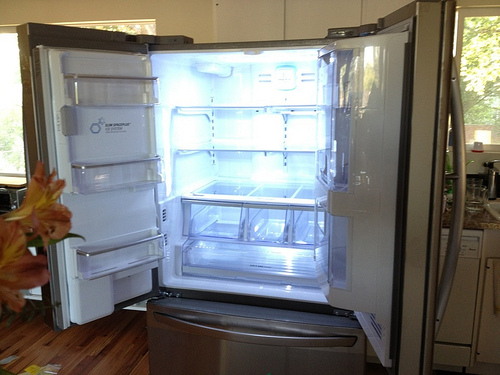Please provide the bounding box coordinate of the region this sentence describes: Large wide glass window. For a large wide glass window, a bounding box of [0.0, 0.12, 0.8, 0.7] would span the significant expanse of the window's dimensions, capturing the feature in its entirety. 